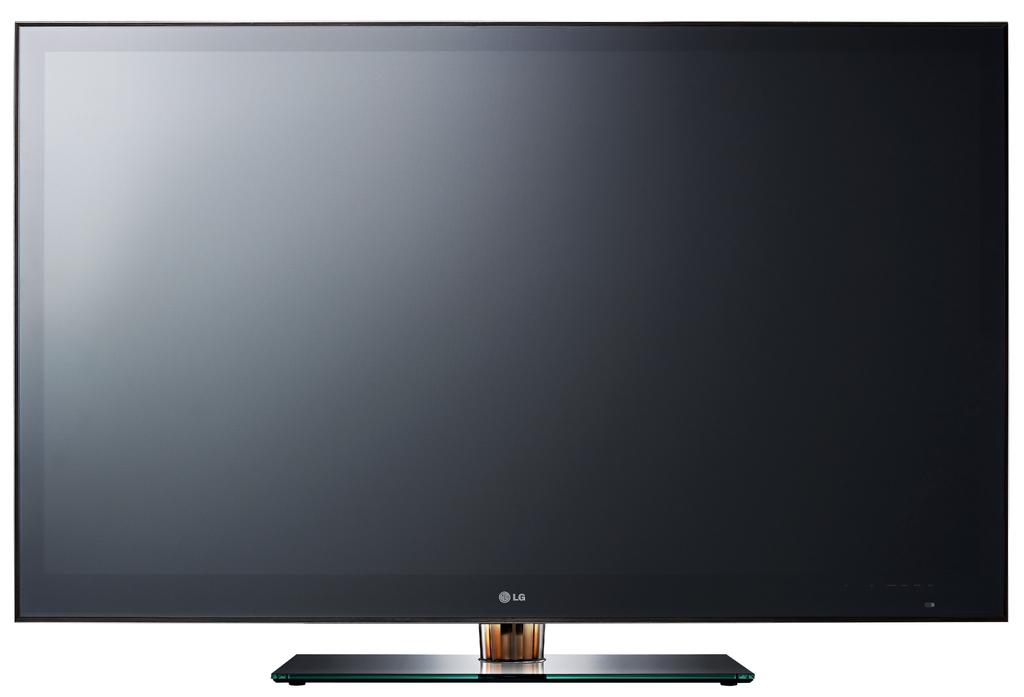<image>
Offer a succinct explanation of the picture presented. a large black thin flat screen computer monitor by lg 